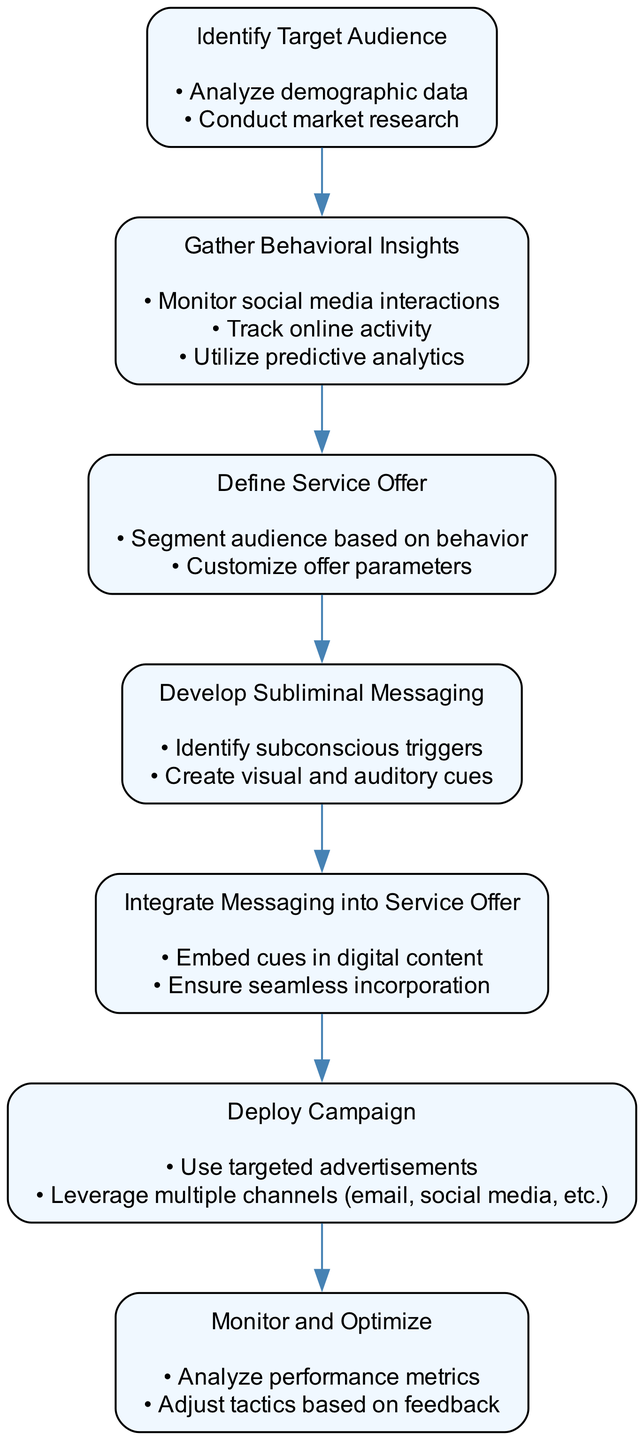What is the first step in the workflow? The first step in the workflow is represented as the top node, which is "Identify Target Audience." This is clearly indicated in the flow chart as the starting point of the process.
Answer: Identify Target Audience How many total steps are there in the diagram? By counting the nodes representing the steps in the diagram, we can see there are seven steps total. This involves systematically identifying each separate stage in the process outlined by the flow chart.
Answer: 7 What action is associated with "Gather Behavioral Insights"? The actions specified under the "Gather Behavioral Insights" step are "Monitor social media interactions," "Track online activity," and "Utilize predictive analytics." These are the distinct tasks mentioned for this step in the diagram.
Answer: Monitor social media interactions, Track online activity, Utilize predictive analytics Which step follows "Develop Subliminal Messaging"? The step that directly follows "Develop Subliminal Messaging" in the flow of the diagram is "Integrate Messaging into Service Offer." This can be determined by looking at the directional arrows connecting the nodes in the flow chart.
Answer: Integrate Messaging into Service Offer What two actions are taken in the "Monitor and Optimize" step? Under "Monitor and Optimize," the actions listed are "Analyze performance metrics" and "Adjust tactics based on feedback." This requires reviewing the specific actions designated for that step in the diagram.
Answer: Analyze performance metrics, Adjust tactics based on feedback Which two steps are related by a direct edge (connection) in the diagram? The steps "Define Service Offer" and "Develop Subliminal Messaging" are directly connected, showing the progression from defining the offer to developing the messaging. This is established by analyzing the directional flow between those two nodes.
Answer: Define Service Offer, Develop Subliminal Messaging What type of advertising is emphasized in the workflow? The workflow emphasizes "subliminal advertising" techniques, particularly in the processes of developing messaging and integrating it into service offers. This reflects the main theme of the flow chart.
Answer: Subliminal advertising Which step involves analyzing demographic data? The step that involves analyzing demographic data is "Identify Target Audience." This is evident by the actions listed under that step in the flow chart.
Answer: Identify Target Audience 